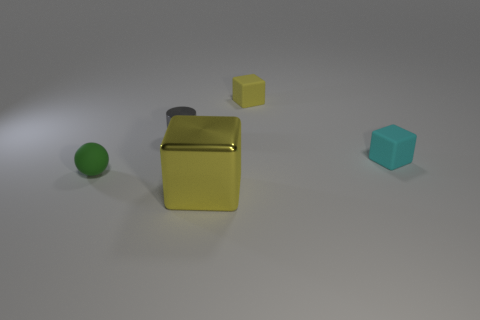There is a large object that is the same shape as the tiny cyan thing; what is it made of?
Give a very brief answer. Metal. There is a yellow thing that is in front of the green object; does it have the same shape as the rubber object that is behind the gray thing?
Offer a very short reply. Yes. Is the number of tiny gray cylinders greater than the number of gray metal balls?
Make the answer very short. Yes. What is the size of the metal cube?
Provide a succinct answer. Large. What number of other objects are the same color as the big metallic thing?
Provide a short and direct response. 1. Are the small cube that is on the left side of the small cyan rubber cube and the tiny gray cylinder made of the same material?
Your response must be concise. No. Is the number of small cyan matte cubes right of the yellow shiny object less than the number of small objects right of the green rubber object?
Offer a very short reply. Yes. What number of other objects are the same material as the large cube?
Make the answer very short. 1. There is a gray cylinder that is the same size as the sphere; what is it made of?
Provide a succinct answer. Metal. Are there fewer gray things that are to the right of the green rubber ball than objects?
Keep it short and to the point. Yes. 